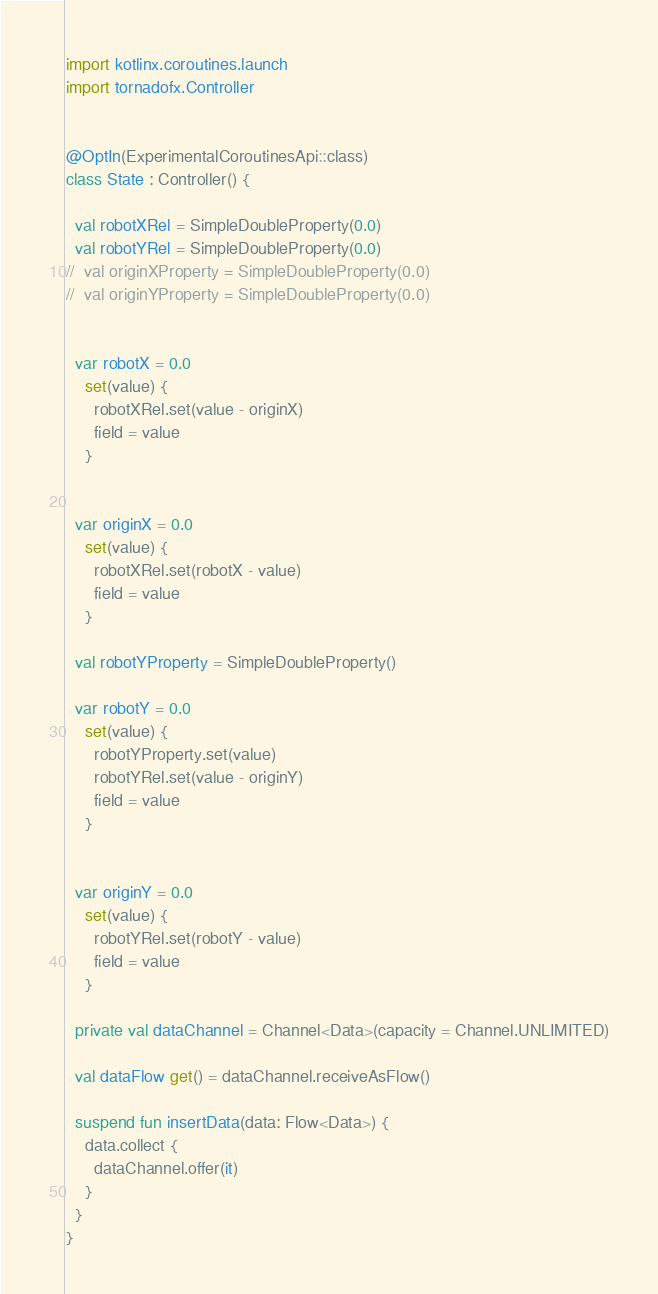<code> <loc_0><loc_0><loc_500><loc_500><_Kotlin_>import kotlinx.coroutines.launch
import tornadofx.Controller


@OptIn(ExperimentalCoroutinesApi::class)
class State : Controller() {

  val robotXRel = SimpleDoubleProperty(0.0)
  val robotYRel = SimpleDoubleProperty(0.0)
//  val originXProperty = SimpleDoubleProperty(0.0)
//  val originYProperty = SimpleDoubleProperty(0.0)


  var robotX = 0.0
    set(value) {
      robotXRel.set(value - originX)
      field = value
    }


  var originX = 0.0
    set(value) {
      robotXRel.set(robotX - value)
      field = value
    }

  val robotYProperty = SimpleDoubleProperty()

  var robotY = 0.0
    set(value) {
      robotYProperty.set(value)
      robotYRel.set(value - originY)
      field = value
    }


  var originY = 0.0
    set(value) {
      robotYRel.set(robotY - value)
      field = value
    }

  private val dataChannel = Channel<Data>(capacity = Channel.UNLIMITED)

  val dataFlow get() = dataChannel.receiveAsFlow()

  suspend fun insertData(data: Flow<Data>) {
    data.collect {
      dataChannel.offer(it)
    }
  }
}
</code> 